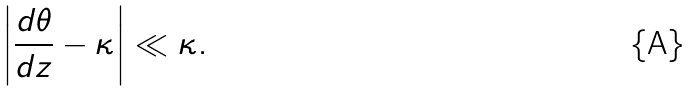<formula> <loc_0><loc_0><loc_500><loc_500>\left | \frac { d \theta } { d z } - \kappa \right | \ll \kappa .</formula> 